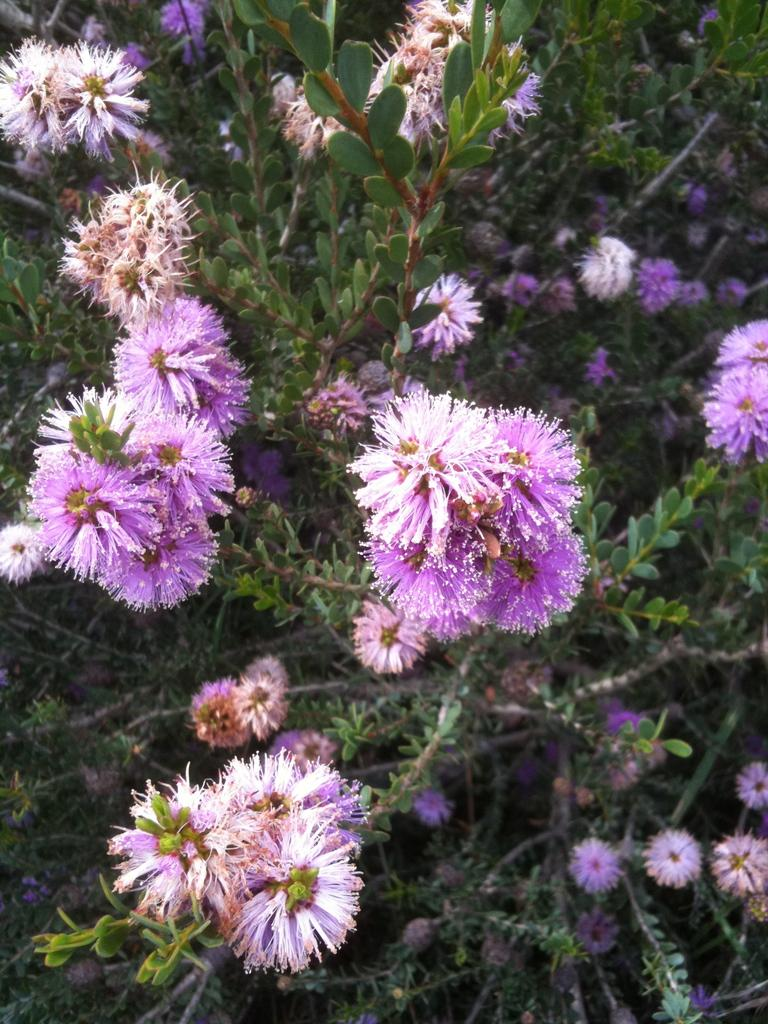What is the main subject of the image? The main subject of the image is many plants. What can be observed about the plants in the image? The plants have beautiful purple flowers. What type of curtain can be seen hanging from the plants in the image? There is no curtain present in the image; it features plants with purple flowers. How many bikes are visible among the plants in the image? There are no bikes present in the image; it features plants with purple flowers. 